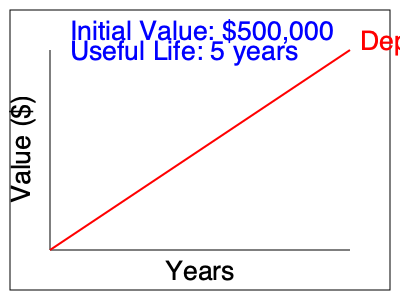Based on the straight-line depreciation method illustrated in the diagram, calculate the annual depreciation expense for a $500,000 film production equipment with a useful life of 5 years and zero salvage value. How much will be the book value of the equipment after 3 years? To solve this problem, we'll follow these steps:

1. Calculate the annual depreciation expense:
   Annual Depreciation = (Initial Value - Salvage Value) / Useful Life
   $$\text{Annual Depreciation} = \frac{\$500,000 - \$0}{5 \text{ years}} = \$100,000$$

2. Calculate the accumulated depreciation after 3 years:
   Accumulated Depreciation = Annual Depreciation × Number of Years
   $$\text{Accumulated Depreciation} = \$100,000 \times 3 \text{ years} = \$300,000$$

3. Calculate the book value after 3 years:
   Book Value = Initial Value - Accumulated Depreciation
   $$\text{Book Value} = \$500,000 - \$300,000 = \$200,000$$

The straight-line method shown in the diagram depicts a constant rate of depreciation over the useful life of the asset, which aligns with our calculations.
Answer: Annual depreciation: $100,000; Book value after 3 years: $200,000 